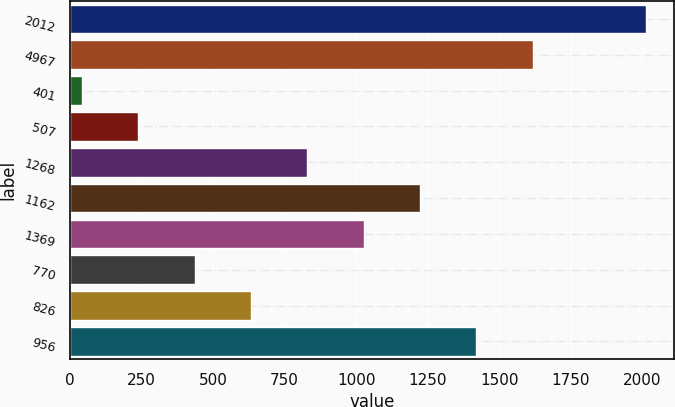Convert chart to OTSL. <chart><loc_0><loc_0><loc_500><loc_500><bar_chart><fcel>2012<fcel>4967<fcel>401<fcel>507<fcel>1268<fcel>1162<fcel>1369<fcel>770<fcel>826<fcel>956<nl><fcel>2011<fcel>1617.26<fcel>42.3<fcel>239.17<fcel>829.78<fcel>1223.52<fcel>1026.65<fcel>436.04<fcel>632.91<fcel>1420.39<nl></chart> 